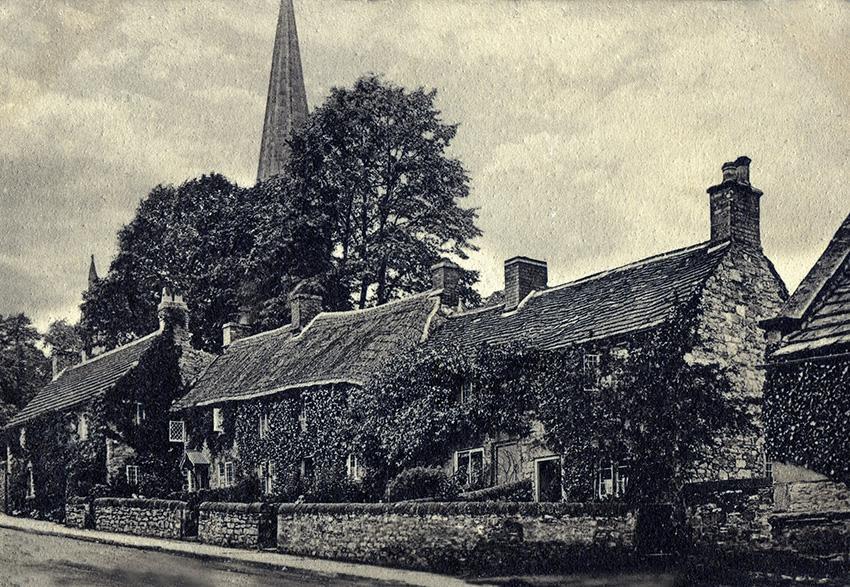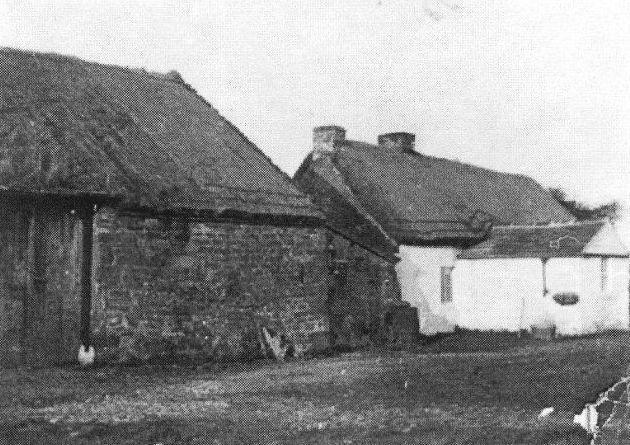The first image is the image on the left, the second image is the image on the right. Evaluate the accuracy of this statement regarding the images: "The left and right image contains the same number of full building with a single chimney on it.". Is it true? Answer yes or no. No. The first image is the image on the left, the second image is the image on the right. For the images displayed, is the sentence "The building in the left image has exactly one chimney." factually correct? Answer yes or no. No. 